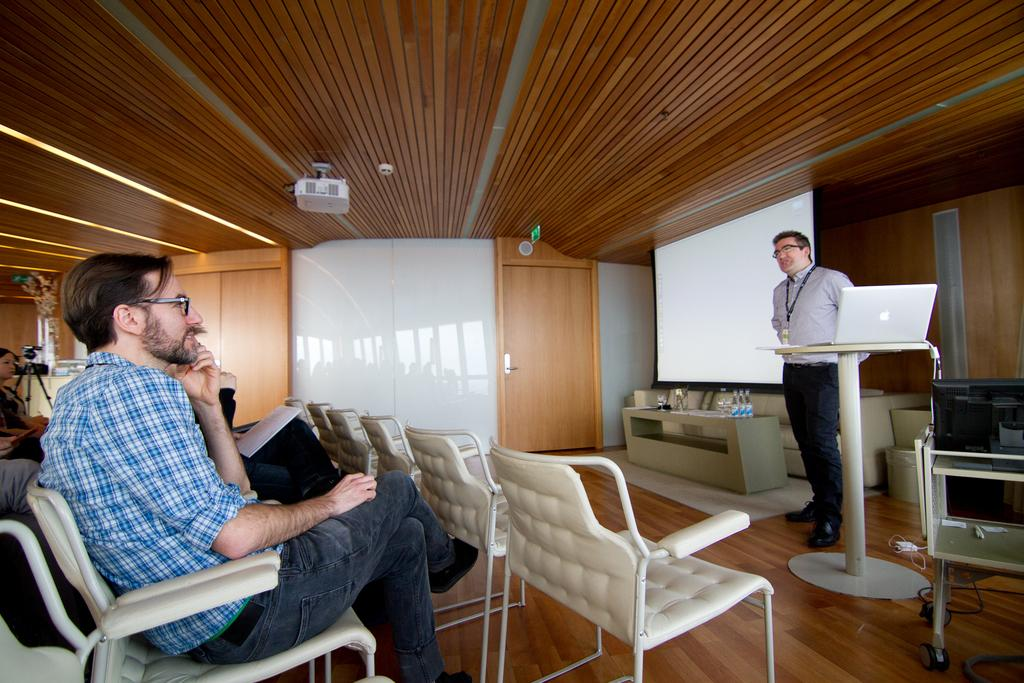What is the position of the man in the image? There is a man seated on a chair and another man standing and speaking in the image. What object is on the table in the image? There is a laptop on a table in the image. What is the purpose of the projector screen in the image? The projector screen is likely used for displaying information or presentations. What device is responsible for projecting onto the screen? There is a projector in the image. What note is the man holding in the image? There is no mention of a note in the image. 